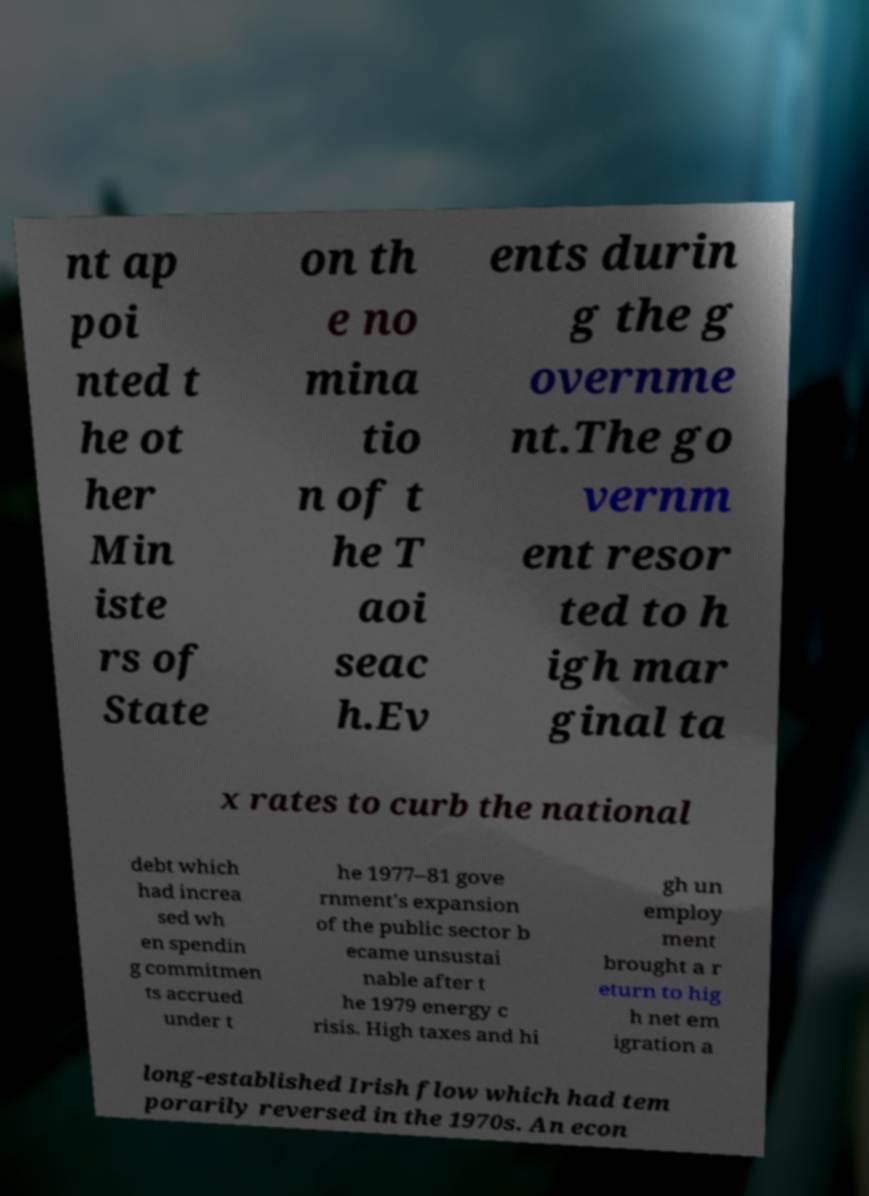Could you assist in decoding the text presented in this image and type it out clearly? nt ap poi nted t he ot her Min iste rs of State on th e no mina tio n of t he T aoi seac h.Ev ents durin g the g overnme nt.The go vernm ent resor ted to h igh mar ginal ta x rates to curb the national debt which had increa sed wh en spendin g commitmen ts accrued under t he 1977–81 gove rnment's expansion of the public sector b ecame unsustai nable after t he 1979 energy c risis. High taxes and hi gh un employ ment brought a r eturn to hig h net em igration a long-established Irish flow which had tem porarily reversed in the 1970s. An econ 